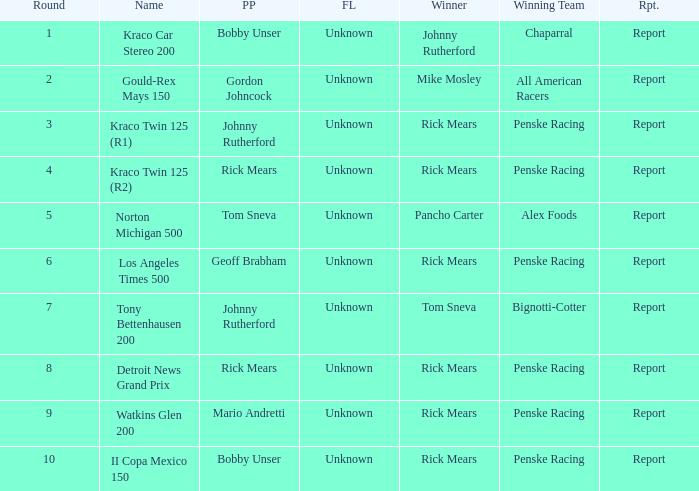How many fastest laps were there for a rd that equals 10? 1.0. 